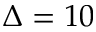Convert formula to latex. <formula><loc_0><loc_0><loc_500><loc_500>\Delta = 1 0</formula> 